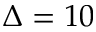Convert formula to latex. <formula><loc_0><loc_0><loc_500><loc_500>\Delta = 1 0</formula> 